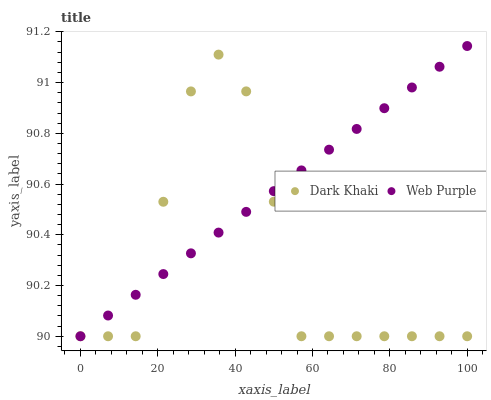Does Dark Khaki have the minimum area under the curve?
Answer yes or no. Yes. Does Web Purple have the maximum area under the curve?
Answer yes or no. Yes. Does Web Purple have the minimum area under the curve?
Answer yes or no. No. Is Web Purple the smoothest?
Answer yes or no. Yes. Is Dark Khaki the roughest?
Answer yes or no. Yes. Is Web Purple the roughest?
Answer yes or no. No. Does Dark Khaki have the lowest value?
Answer yes or no. Yes. Does Web Purple have the highest value?
Answer yes or no. Yes. Does Dark Khaki intersect Web Purple?
Answer yes or no. Yes. Is Dark Khaki less than Web Purple?
Answer yes or no. No. Is Dark Khaki greater than Web Purple?
Answer yes or no. No. 